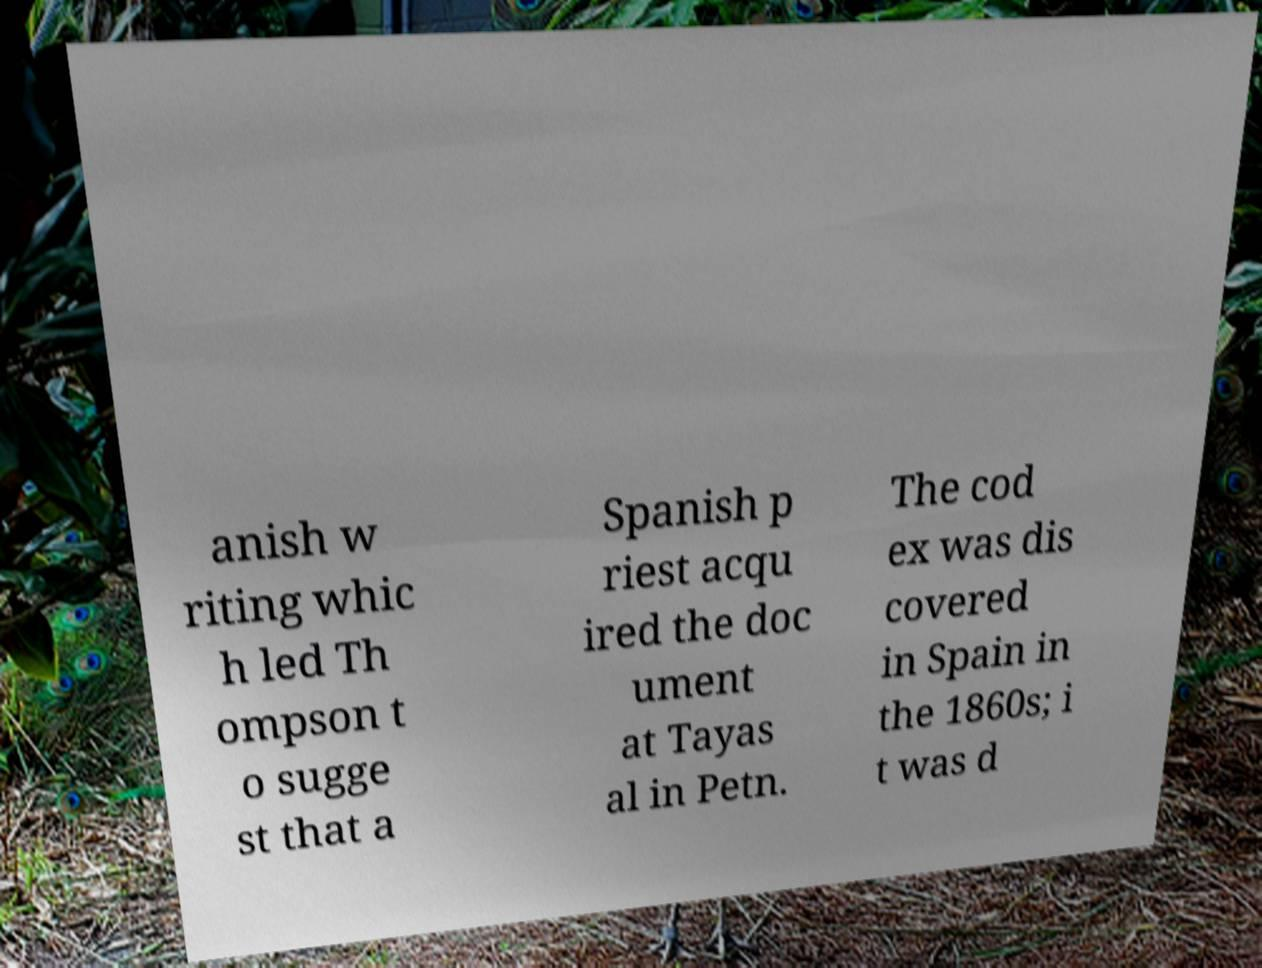Can you read and provide the text displayed in the image?This photo seems to have some interesting text. Can you extract and type it out for me? anish w riting whic h led Th ompson t o sugge st that a Spanish p riest acqu ired the doc ument at Tayas al in Petn. The cod ex was dis covered in Spain in the 1860s; i t was d 